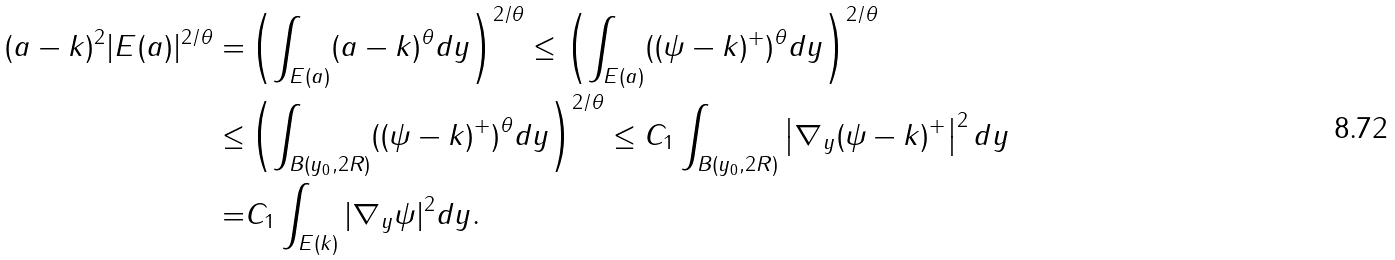Convert formula to latex. <formula><loc_0><loc_0><loc_500><loc_500>( a - k ) ^ { 2 } | E ( a ) | ^ { 2 / \theta } = & \left ( \int _ { E ( a ) } ( a - k ) ^ { \theta } d y \right ) ^ { 2 / \theta } \leq \left ( \int _ { E ( a ) } ( ( \psi - k ) ^ { + } ) ^ { \theta } d y \right ) ^ { 2 / \theta } \\ \leq & \left ( \int _ { B ( y _ { 0 } , 2 R ) } ( ( \psi - k ) ^ { + } ) ^ { \theta } d y \right ) ^ { 2 / \theta } \leq C _ { 1 } \int _ { B ( y _ { 0 } , 2 R ) } \left | \nabla _ { y } ( \psi - k ) ^ { + } \right | ^ { 2 } d y \\ = & C _ { 1 } \int _ { E ( k ) } | \nabla _ { y } \psi | ^ { 2 } d y .</formula> 